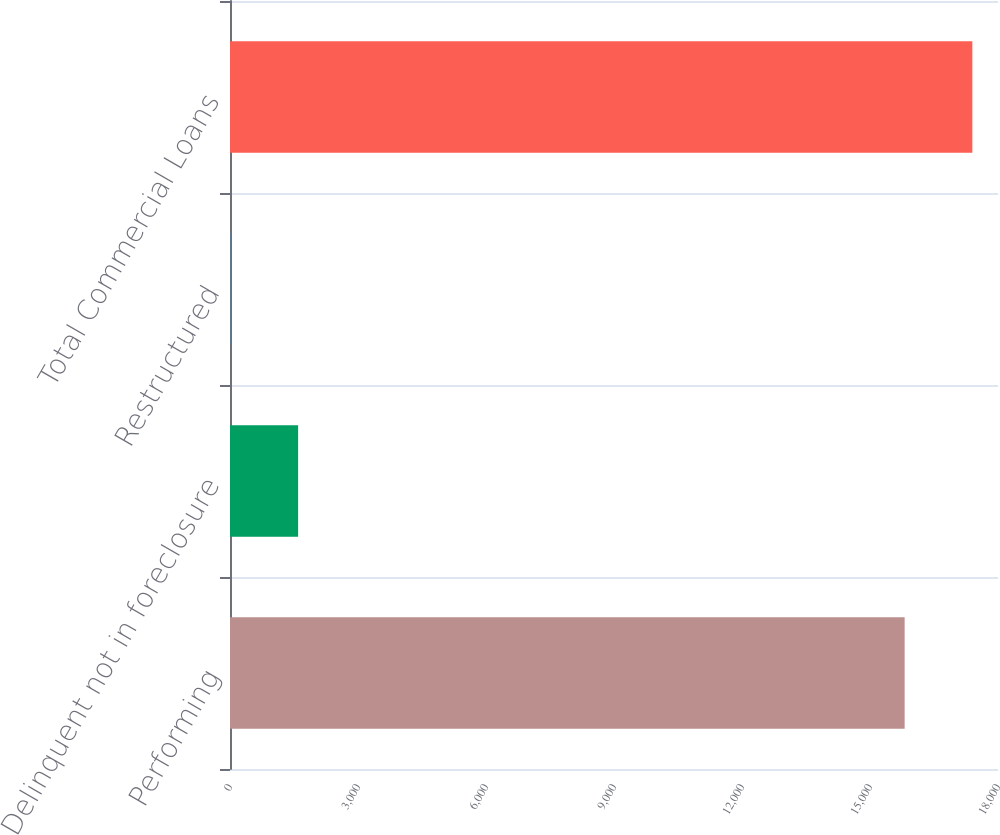<chart> <loc_0><loc_0><loc_500><loc_500><bar_chart><fcel>Performing<fcel>Delinquent not in foreclosure<fcel>Restructured<fcel>Total Commercial Loans<nl><fcel>15812<fcel>1596.4<fcel>10<fcel>17398.4<nl></chart> 